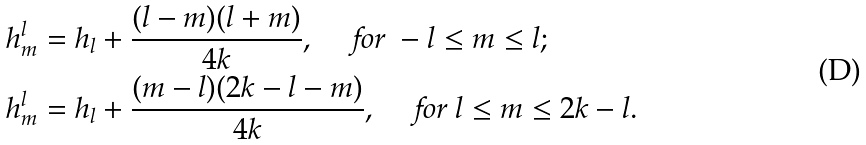Convert formula to latex. <formula><loc_0><loc_0><loc_500><loc_500>h ^ { l } _ { m } & = h _ { l } + \frac { ( l - m ) ( l + m ) } { 4 k } , \quad \text { for } - l \leq m \leq l ; \\ h ^ { l } _ { m } & = h _ { l } + \frac { ( m - l ) ( 2 k - l - m ) } { 4 k } , \quad \text { for } l \leq m \leq 2 k - l .</formula> 